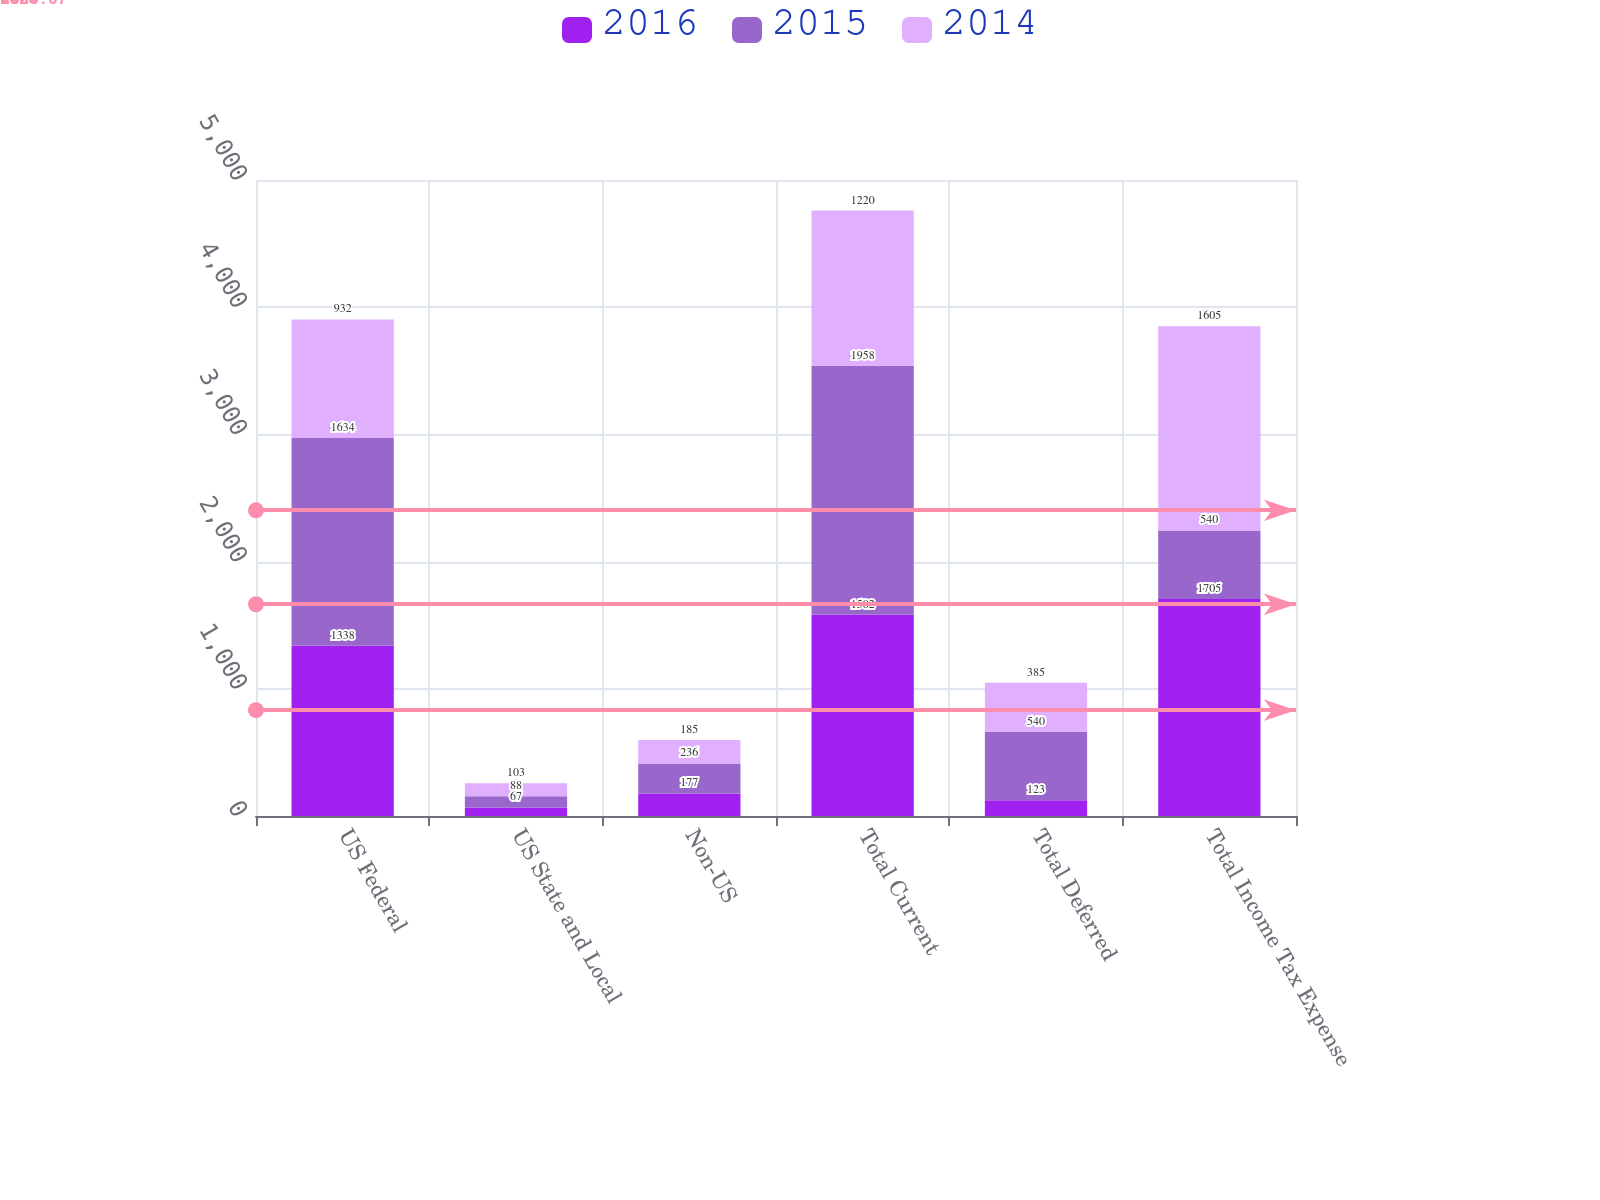<chart> <loc_0><loc_0><loc_500><loc_500><stacked_bar_chart><ecel><fcel>US Federal<fcel>US State and Local<fcel>Non-US<fcel>Total Current<fcel>Total Deferred<fcel>Total Income Tax Expense<nl><fcel>2016<fcel>1338<fcel>67<fcel>177<fcel>1582<fcel>123<fcel>1705<nl><fcel>2015<fcel>1634<fcel>88<fcel>236<fcel>1958<fcel>540<fcel>540<nl><fcel>2014<fcel>932<fcel>103<fcel>185<fcel>1220<fcel>385<fcel>1605<nl></chart> 